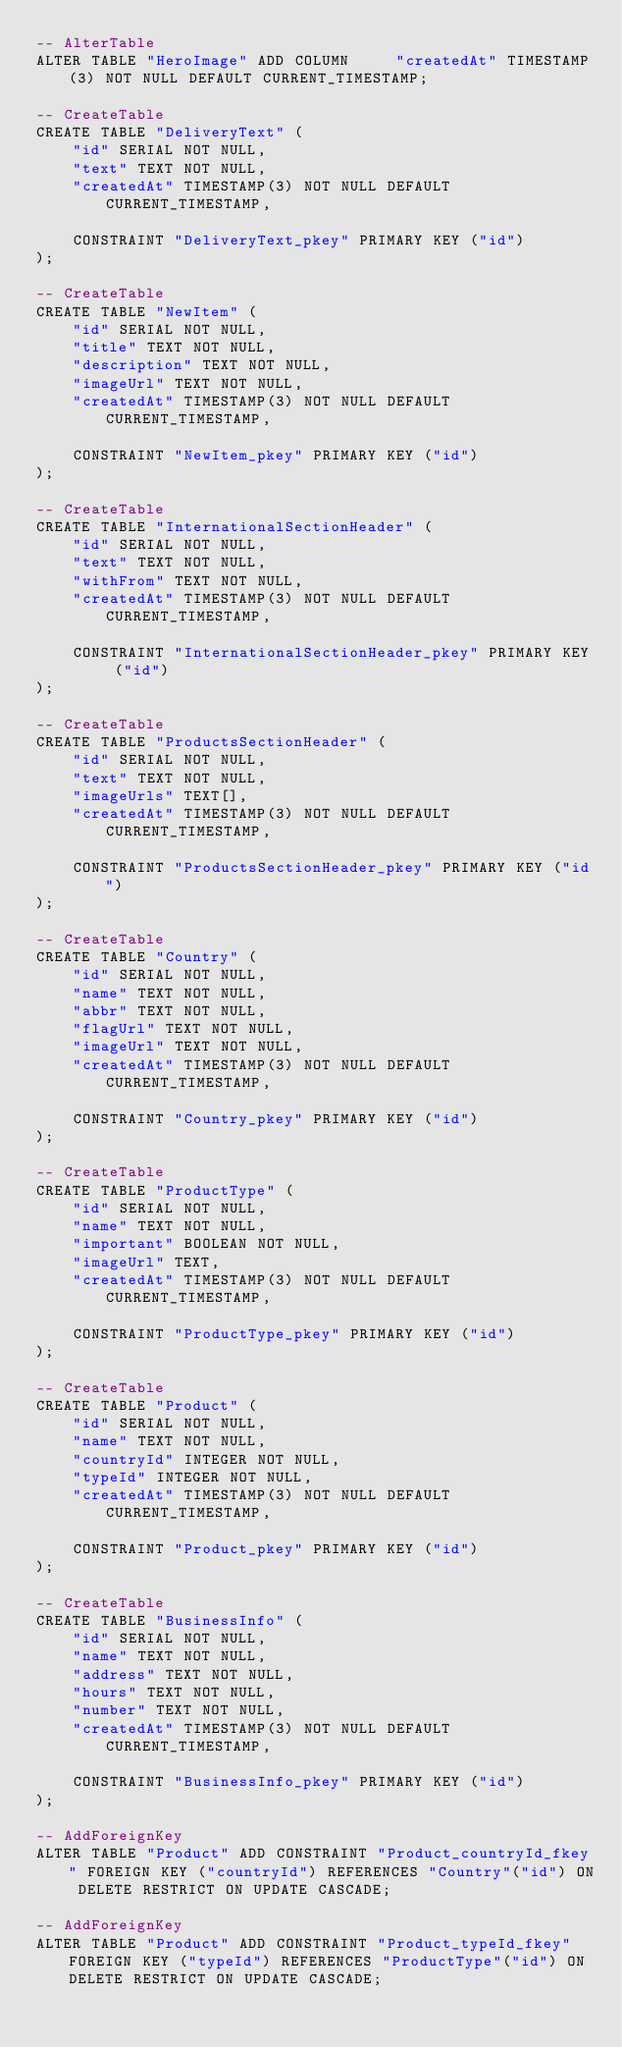<code> <loc_0><loc_0><loc_500><loc_500><_SQL_>-- AlterTable
ALTER TABLE "HeroImage" ADD COLUMN     "createdAt" TIMESTAMP(3) NOT NULL DEFAULT CURRENT_TIMESTAMP;

-- CreateTable
CREATE TABLE "DeliveryText" (
    "id" SERIAL NOT NULL,
    "text" TEXT NOT NULL,
    "createdAt" TIMESTAMP(3) NOT NULL DEFAULT CURRENT_TIMESTAMP,

    CONSTRAINT "DeliveryText_pkey" PRIMARY KEY ("id")
);

-- CreateTable
CREATE TABLE "NewItem" (
    "id" SERIAL NOT NULL,
    "title" TEXT NOT NULL,
    "description" TEXT NOT NULL,
    "imageUrl" TEXT NOT NULL,
    "createdAt" TIMESTAMP(3) NOT NULL DEFAULT CURRENT_TIMESTAMP,

    CONSTRAINT "NewItem_pkey" PRIMARY KEY ("id")
);

-- CreateTable
CREATE TABLE "InternationalSectionHeader" (
    "id" SERIAL NOT NULL,
    "text" TEXT NOT NULL,
    "withFrom" TEXT NOT NULL,
    "createdAt" TIMESTAMP(3) NOT NULL DEFAULT CURRENT_TIMESTAMP,

    CONSTRAINT "InternationalSectionHeader_pkey" PRIMARY KEY ("id")
);

-- CreateTable
CREATE TABLE "ProductsSectionHeader" (
    "id" SERIAL NOT NULL,
    "text" TEXT NOT NULL,
    "imageUrls" TEXT[],
    "createdAt" TIMESTAMP(3) NOT NULL DEFAULT CURRENT_TIMESTAMP,

    CONSTRAINT "ProductsSectionHeader_pkey" PRIMARY KEY ("id")
);

-- CreateTable
CREATE TABLE "Country" (
    "id" SERIAL NOT NULL,
    "name" TEXT NOT NULL,
    "abbr" TEXT NOT NULL,
    "flagUrl" TEXT NOT NULL,
    "imageUrl" TEXT NOT NULL,
    "createdAt" TIMESTAMP(3) NOT NULL DEFAULT CURRENT_TIMESTAMP,

    CONSTRAINT "Country_pkey" PRIMARY KEY ("id")
);

-- CreateTable
CREATE TABLE "ProductType" (
    "id" SERIAL NOT NULL,
    "name" TEXT NOT NULL,
    "important" BOOLEAN NOT NULL,
    "imageUrl" TEXT,
    "createdAt" TIMESTAMP(3) NOT NULL DEFAULT CURRENT_TIMESTAMP,

    CONSTRAINT "ProductType_pkey" PRIMARY KEY ("id")
);

-- CreateTable
CREATE TABLE "Product" (
    "id" SERIAL NOT NULL,
    "name" TEXT NOT NULL,
    "countryId" INTEGER NOT NULL,
    "typeId" INTEGER NOT NULL,
    "createdAt" TIMESTAMP(3) NOT NULL DEFAULT CURRENT_TIMESTAMP,

    CONSTRAINT "Product_pkey" PRIMARY KEY ("id")
);

-- CreateTable
CREATE TABLE "BusinessInfo" (
    "id" SERIAL NOT NULL,
    "name" TEXT NOT NULL,
    "address" TEXT NOT NULL,
    "hours" TEXT NOT NULL,
    "number" TEXT NOT NULL,
    "createdAt" TIMESTAMP(3) NOT NULL DEFAULT CURRENT_TIMESTAMP,

    CONSTRAINT "BusinessInfo_pkey" PRIMARY KEY ("id")
);

-- AddForeignKey
ALTER TABLE "Product" ADD CONSTRAINT "Product_countryId_fkey" FOREIGN KEY ("countryId") REFERENCES "Country"("id") ON DELETE RESTRICT ON UPDATE CASCADE;

-- AddForeignKey
ALTER TABLE "Product" ADD CONSTRAINT "Product_typeId_fkey" FOREIGN KEY ("typeId") REFERENCES "ProductType"("id") ON DELETE RESTRICT ON UPDATE CASCADE;
</code> 